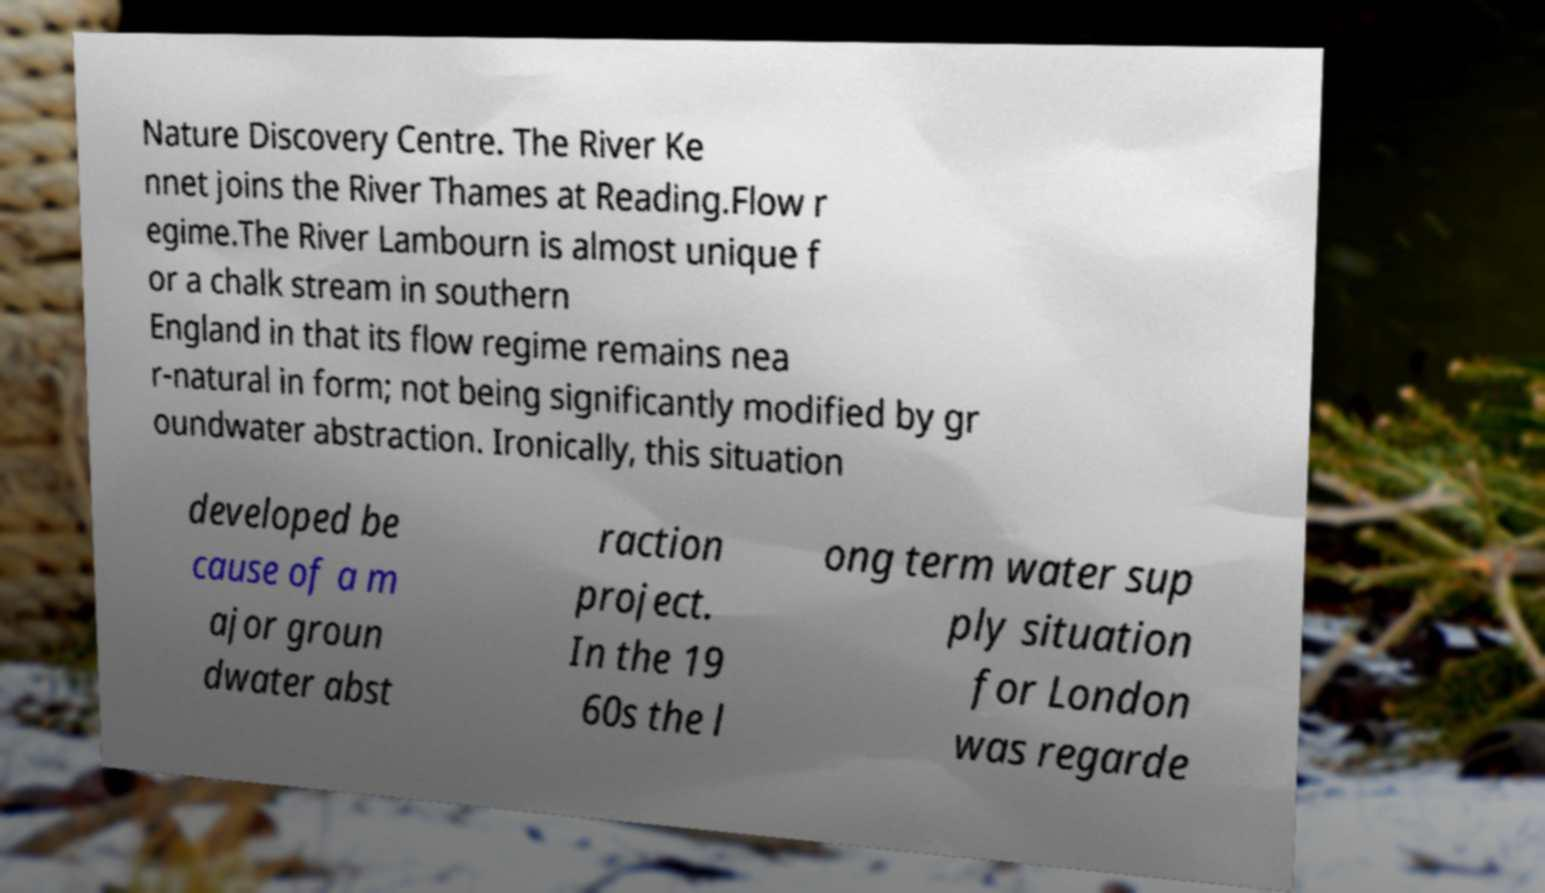Can you accurately transcribe the text from the provided image for me? Nature Discovery Centre. The River Ke nnet joins the River Thames at Reading.Flow r egime.The River Lambourn is almost unique f or a chalk stream in southern England in that its flow regime remains nea r-natural in form; not being significantly modified by gr oundwater abstraction. Ironically, this situation developed be cause of a m ajor groun dwater abst raction project. In the 19 60s the l ong term water sup ply situation for London was regarde 